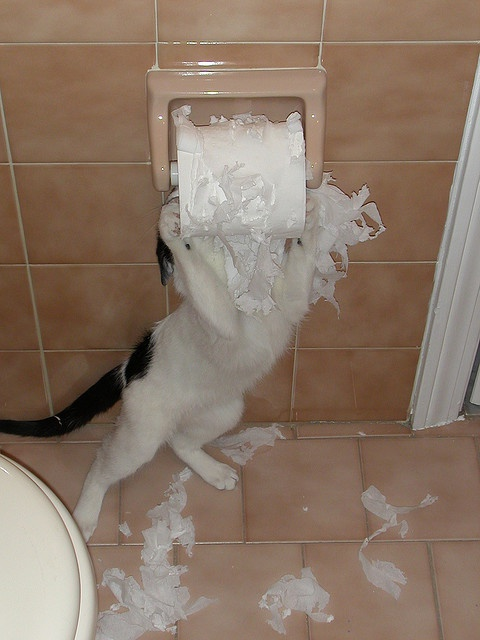Describe the objects in this image and their specific colors. I can see cat in gray and darkgray tones and toilet in gray, lightgray, and darkgray tones in this image. 